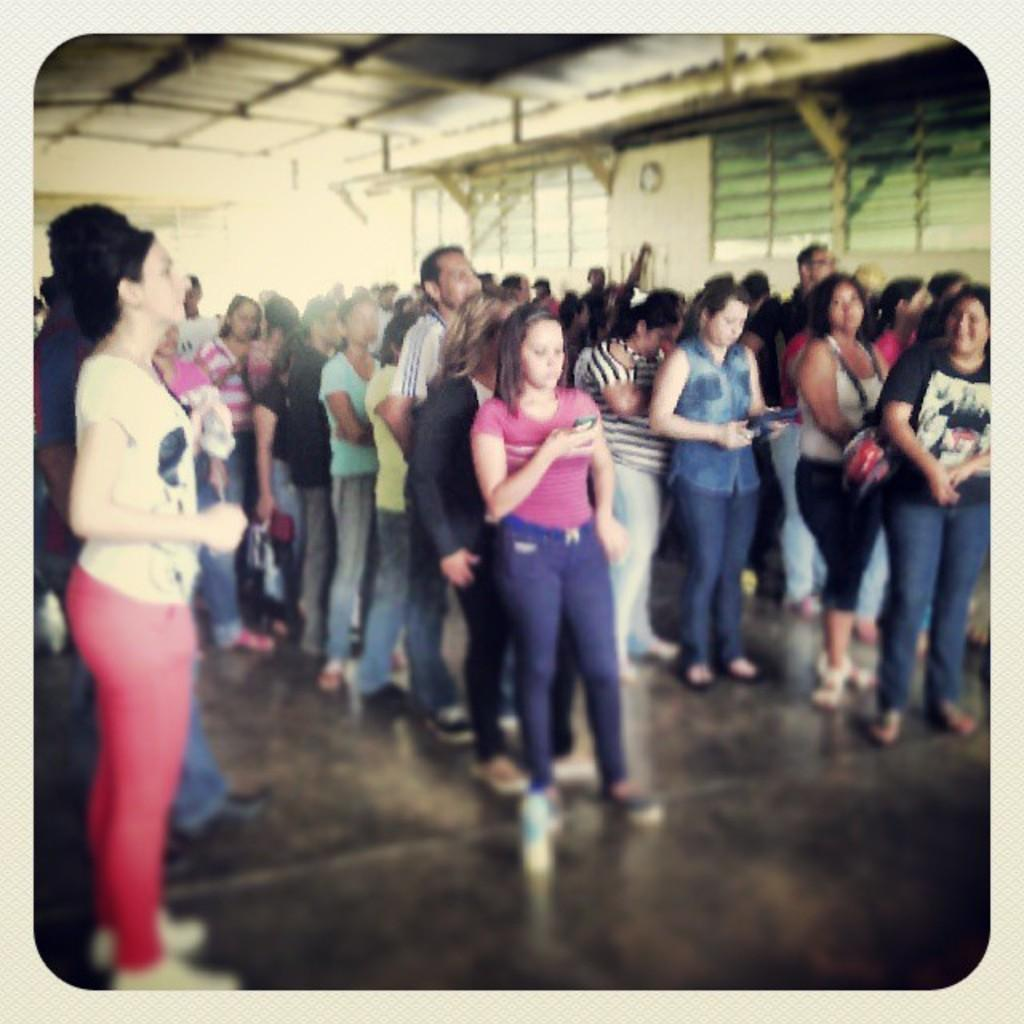How many people are in the image? There is a group of people in the image. What are the people doing in the image? The people are standing in the image. Where are the people located in the image? The people are in a shed in the image. What can be seen in the background of the image? There are metal rods visible in the background of the image. What time of day is it in the image, considering the afternoon? The time of day cannot be determined from the image, as there is no indication of the time or the presence of the afternoon. 